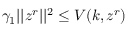Convert formula to latex. <formula><loc_0><loc_0><loc_500><loc_500>\gamma _ { 1 } | | z ^ { r } | | ^ { 2 } \leq V ( k , z ^ { r } )</formula> 